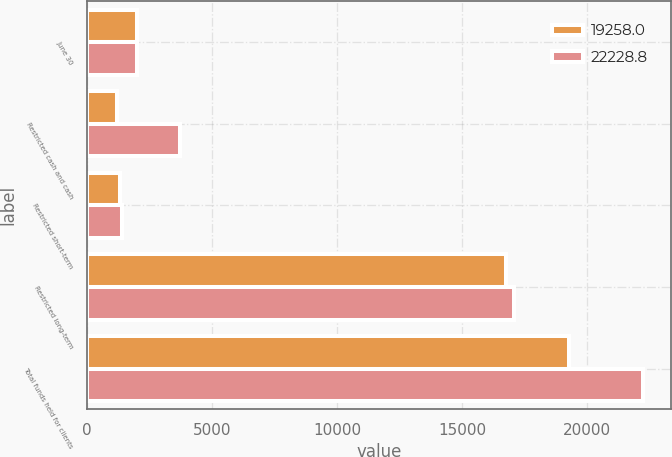Convert chart to OTSL. <chart><loc_0><loc_0><loc_500><loc_500><stacked_bar_chart><ecel><fcel>June 30<fcel>Restricted cash and cash<fcel>Restricted short-term<fcel>Restricted long-term<fcel>Total funds held for clients<nl><fcel>19258<fcel>2014<fcel>1187.8<fcel>1312.5<fcel>16757.7<fcel>19258<nl><fcel>22228.8<fcel>2013<fcel>3732.1<fcel>1407.7<fcel>17089<fcel>22228.8<nl></chart> 